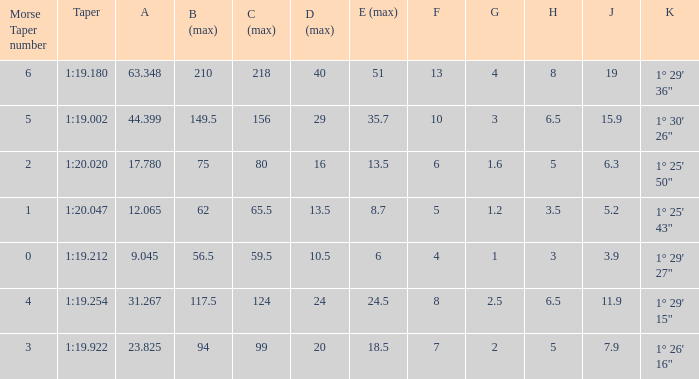Name the h when c max is 99 5.0. 